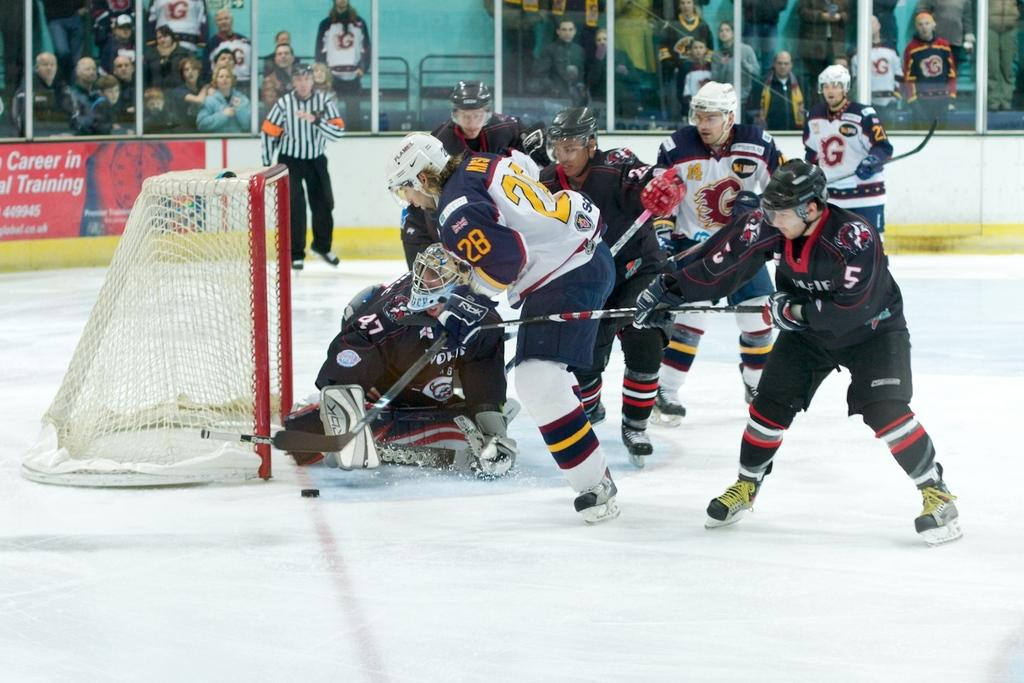Provide a one-sentence caption for the provided image. a hockey game played in front of an ad about "Career in Training". 